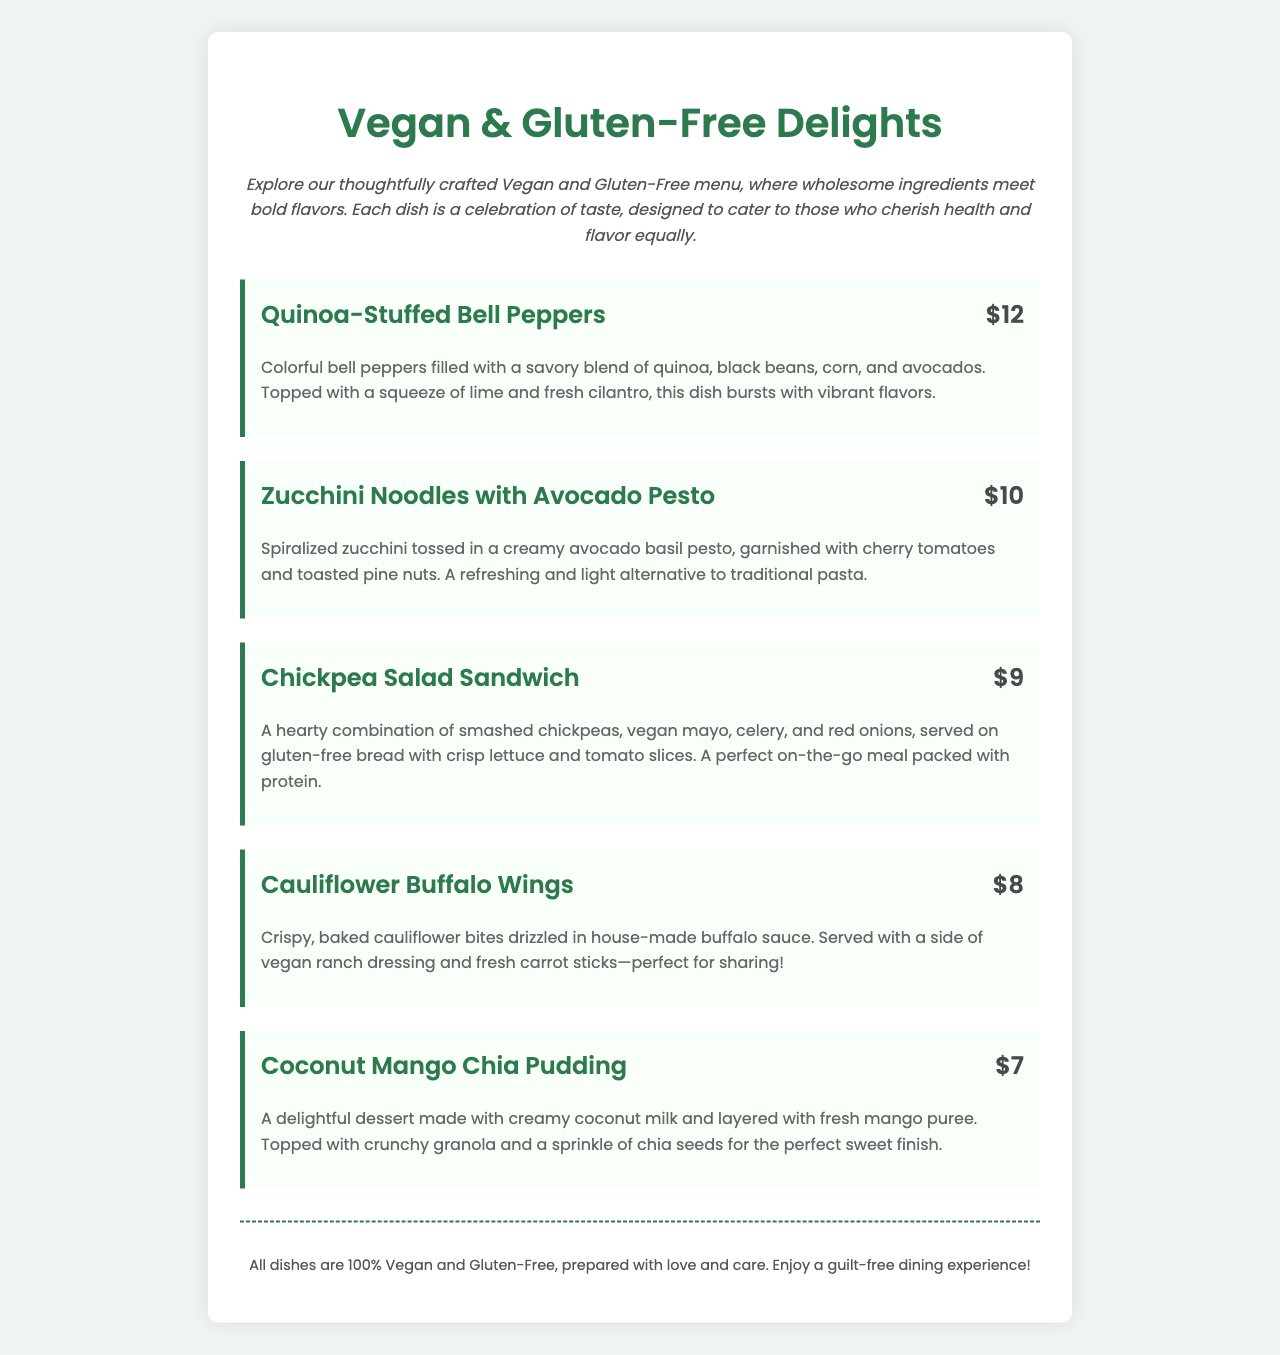What is the title of the menu? The title of the menu is prominently displayed at the top of the document.
Answer: Vegan & Gluten-Free Delights How much do the Quinoa-Stuffed Bell Peppers cost? The price of the Quinoa-Stuffed Bell Peppers is listed next to the dish in the menu.
Answer: $12 Which dish is served with vegan ranch dressing? The dish served with vegan ranch dressing is specifically mentioned in its description.
Answer: Cauliflower Buffalo Wings What is the main ingredient in the Zucchini Noodles with Avocado Pesto? The main ingredient is highlighted in the name and description of the dish.
Answer: Zucchini How many items are featured in the menu? The total number of menu items can be counted in the main section of the document.
Answer: 5 